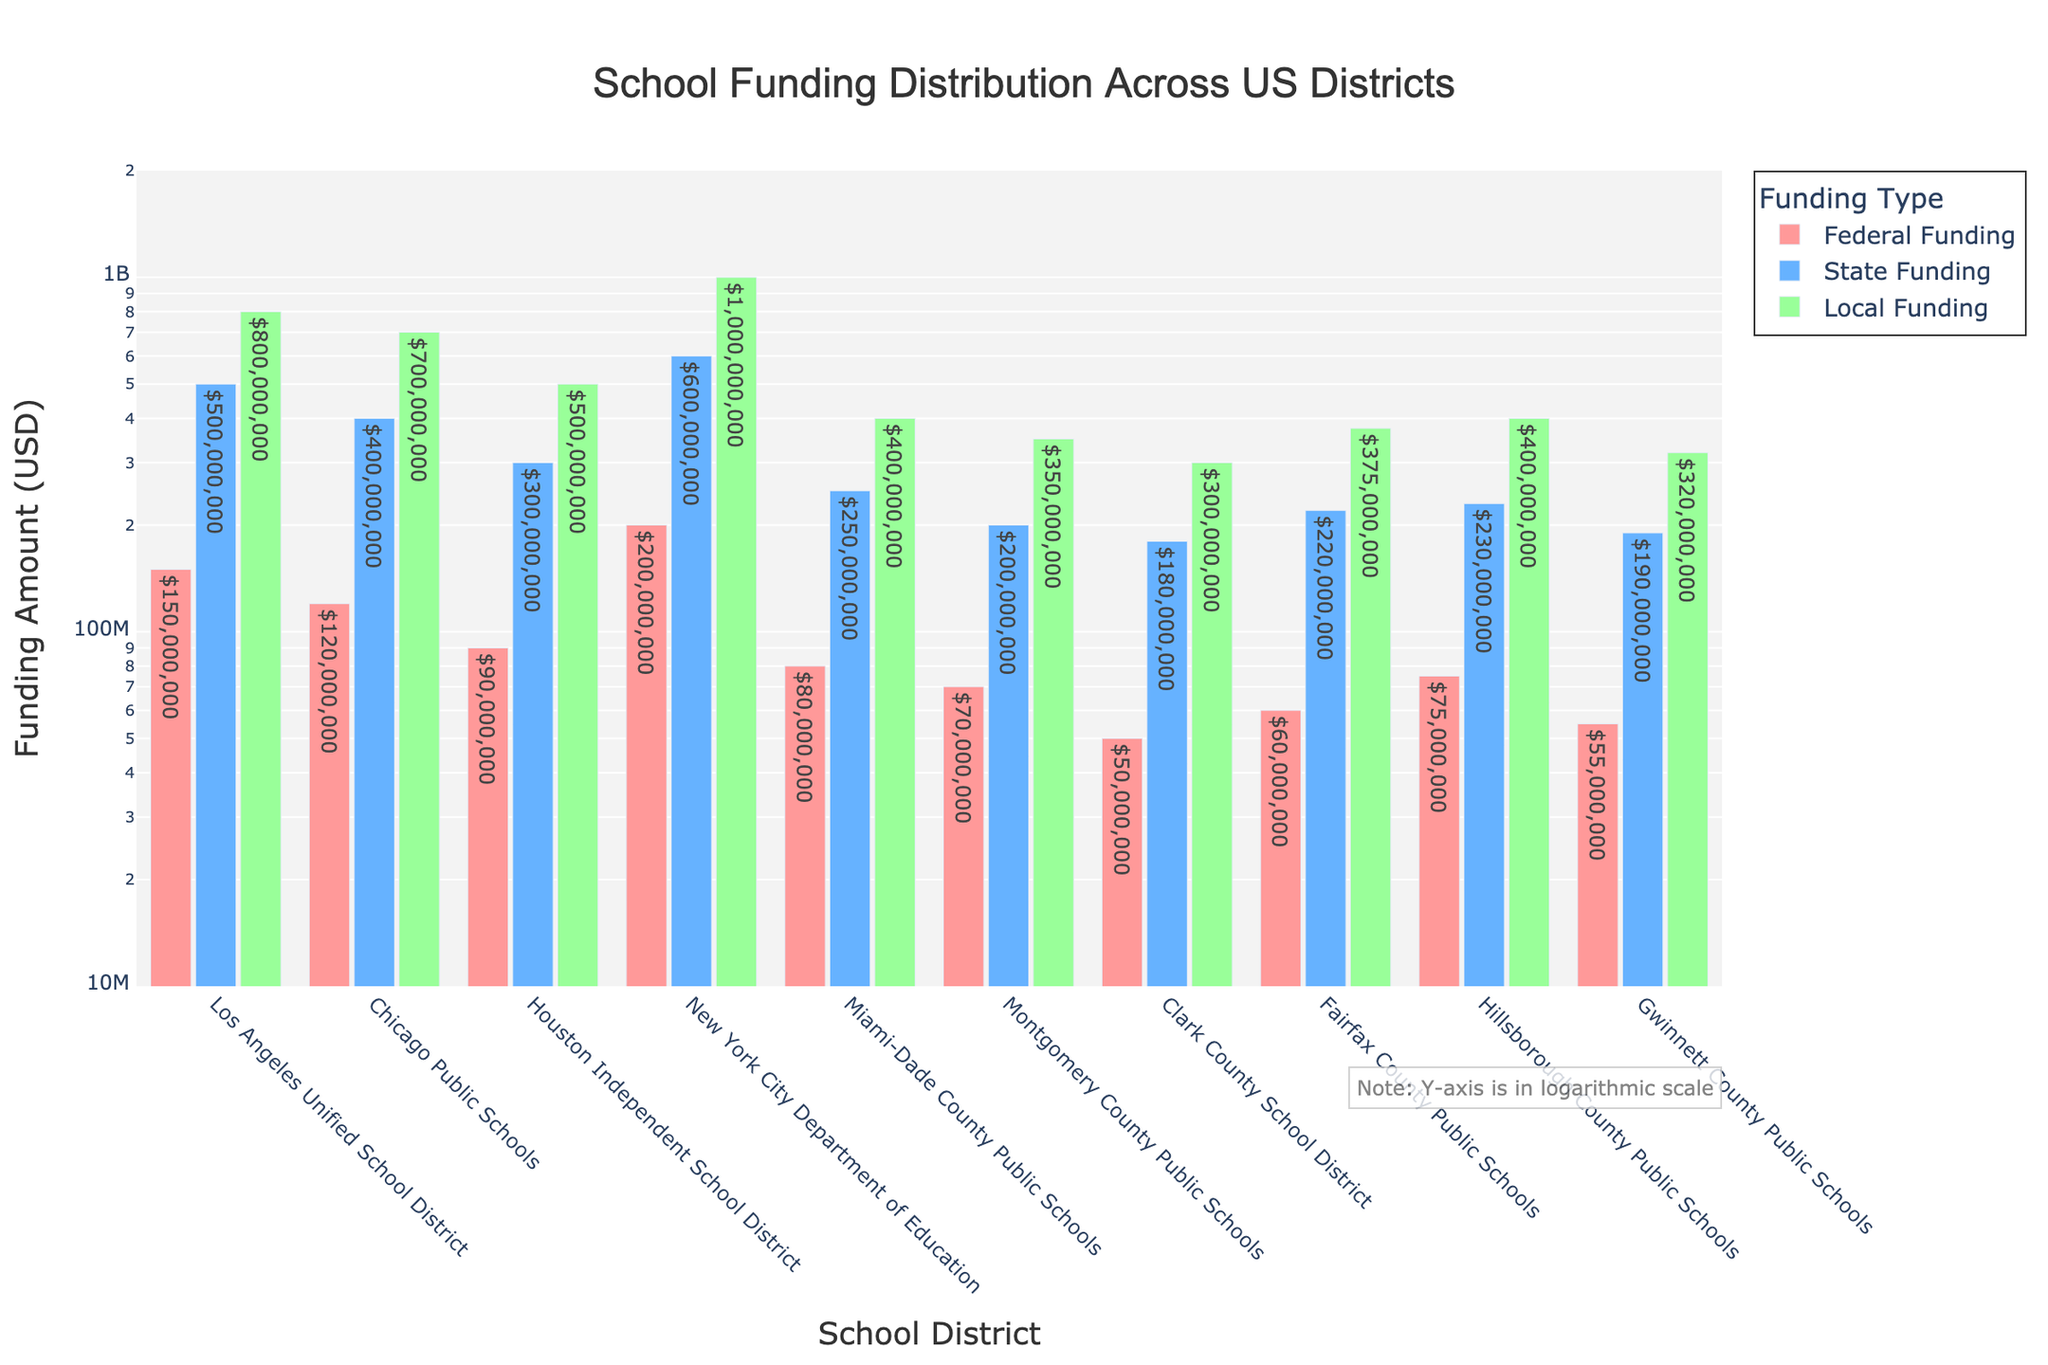What is the title of the figure? The title is located at the top of the figure in a larger font size and typically gives a summary of what the plot is depicting. In this case, the title reads "School Funding Distribution Across US Districts".
Answer: School Funding Distribution Across US Districts How many school districts are represented in the figure? The x-axis lists the school districts. Counting each unique district name, we find there are 10 districts represented.
Answer: 10 Which school district receives the highest local funding? The color for local funding in the figure is green. By checking the height of the green bars, we can see that New York City Department of Education has the highest local funding.
Answer: New York City Department of Education How does federal funding compare between Los Angeles Unified School District and Chicago Public Schools? The red bars represent federal funding. Comparing the heights of the red bars for these two districts, Los Angeles Unified School District receives more federal funding than Chicago Public Schools.
Answer: Los Angeles Unified School District What is the sum of state funding for Miami-Dade County Public Schools and Gwinnett County Public Schools? To find the sum, we look for the blue bars corresponding to these districts and add their values: $250,000,000 (Miami-Dade) + $190,000,000 (Gwinnett) = $440,000,000.
Answer: $440,000,000 Which district receives the lowest state funding and what is the value? The shortest blue bar represents the lowest state funding. This is Clark County School District with $180,000,000.
Answer: Clark County School District with $180,000,000 Which funding type shows the greatest disparity among districts? Observing the variability in the heights of the bars (red, blue, and green), local funding (green bars) shows the greatest disparity in funding amounts across districts.
Answer: Local Funding Which two districts have the most similar total funding amounts? Adding up federal, state, and local funding for each district and comparing totals, Hillsborough County Public Schools and Fairfax County Public Schools have similar totals: Hillsborough ($75,000,000 + $230,000,000 + $400,000,000 = $705,000,000) and Fairfax ($60,000,000 + $220,000,000 + $375,000,000 = $655,000,000).
Answer: Hillsborough County Public Schools and Fairfax County Public Schools What observation can be made about the distribution pattern based on the log scale? The y-axis uses a logarithmic scale, which means differences in funding are scaled exponentially. Despite the large variations, the disparities are visually adjusted to emphasize proportional differences. This shows more clearly the funding disparities and outliers such as New York having significantly higher local funding.
Answer: Log scale emphasizes proportional differences, revealing disparities and outliers clearly Why might a logarithmic scale be used for this plot? A logarithmic scale is utilized when data spans several orders of magnitude, as it reduces skewness and allows both smaller and larger values to be represented more clearly across the same plot. The funding amounts vary greatly and a log scale helps visualize these disparities effectively.
Answer: To represent large variations in funding amounts more clearly 